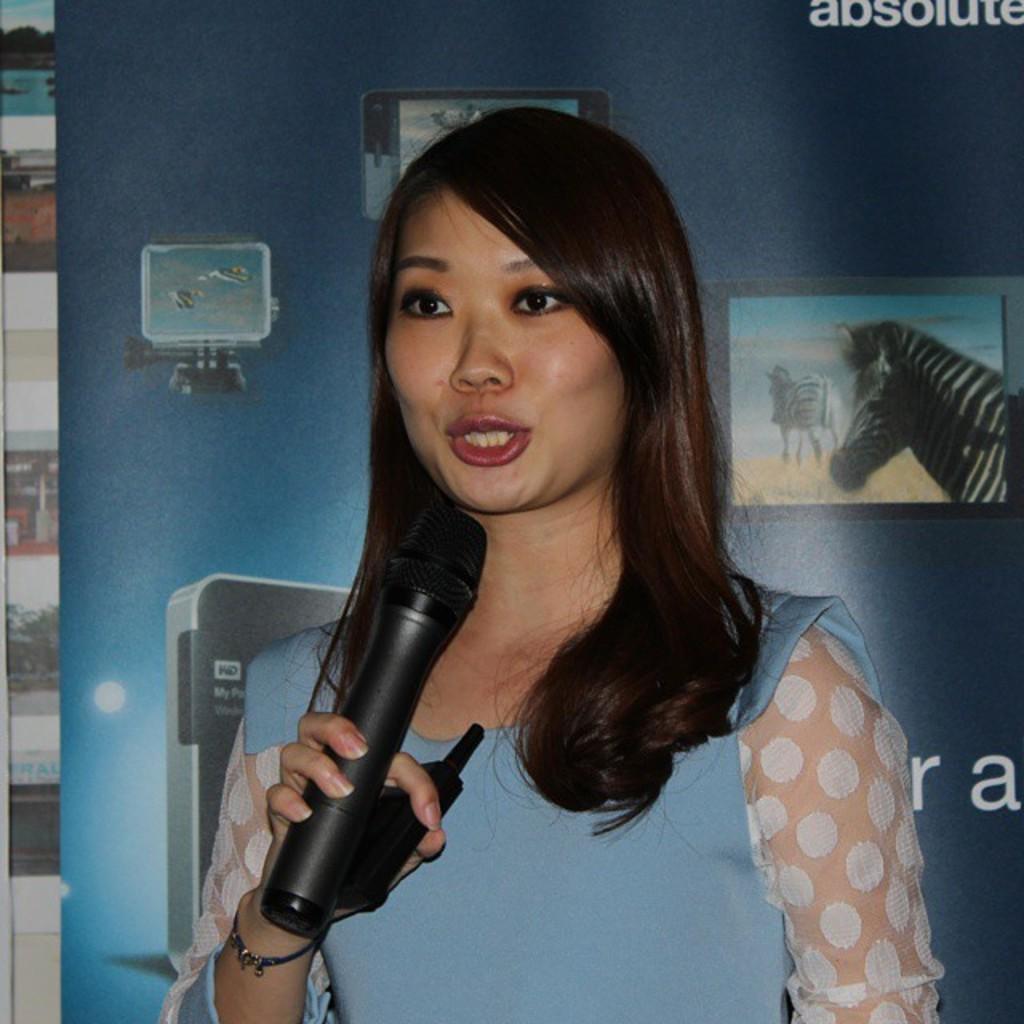Please provide a concise description of this image. In the image we can see there is a woman who is holding a mike in her hand. 